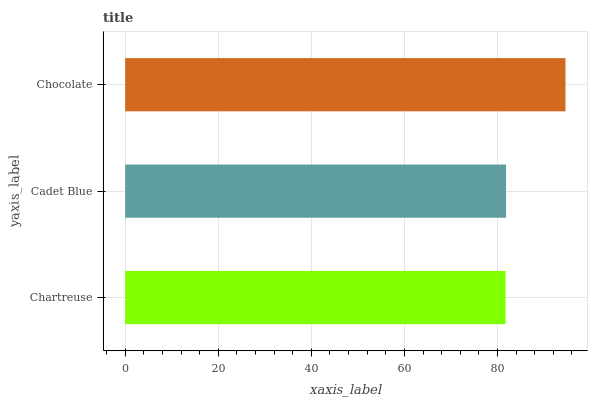Is Chartreuse the minimum?
Answer yes or no. Yes. Is Chocolate the maximum?
Answer yes or no. Yes. Is Cadet Blue the minimum?
Answer yes or no. No. Is Cadet Blue the maximum?
Answer yes or no. No. Is Cadet Blue greater than Chartreuse?
Answer yes or no. Yes. Is Chartreuse less than Cadet Blue?
Answer yes or no. Yes. Is Chartreuse greater than Cadet Blue?
Answer yes or no. No. Is Cadet Blue less than Chartreuse?
Answer yes or no. No. Is Cadet Blue the high median?
Answer yes or no. Yes. Is Cadet Blue the low median?
Answer yes or no. Yes. Is Chartreuse the high median?
Answer yes or no. No. Is Chocolate the low median?
Answer yes or no. No. 